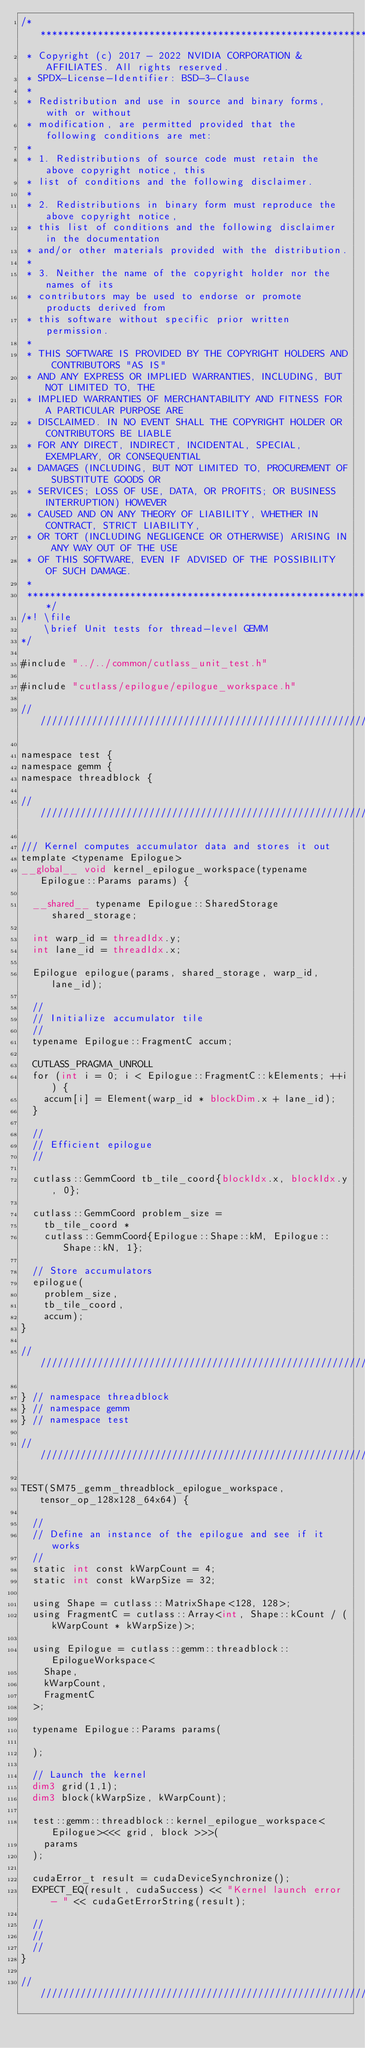Convert code to text. <code><loc_0><loc_0><loc_500><loc_500><_Cuda_>/***************************************************************************************************
 * Copyright (c) 2017 - 2022 NVIDIA CORPORATION & AFFILIATES. All rights reserved.
 * SPDX-License-Identifier: BSD-3-Clause
 *
 * Redistribution and use in source and binary forms, with or without
 * modification, are permitted provided that the following conditions are met:
 *
 * 1. Redistributions of source code must retain the above copyright notice, this
 * list of conditions and the following disclaimer.
 *
 * 2. Redistributions in binary form must reproduce the above copyright notice,
 * this list of conditions and the following disclaimer in the documentation
 * and/or other materials provided with the distribution.
 *
 * 3. Neither the name of the copyright holder nor the names of its
 * contributors may be used to endorse or promote products derived from
 * this software without specific prior written permission.
 *
 * THIS SOFTWARE IS PROVIDED BY THE COPYRIGHT HOLDERS AND CONTRIBUTORS "AS IS"
 * AND ANY EXPRESS OR IMPLIED WARRANTIES, INCLUDING, BUT NOT LIMITED TO, THE
 * IMPLIED WARRANTIES OF MERCHANTABILITY AND FITNESS FOR A PARTICULAR PURPOSE ARE
 * DISCLAIMED. IN NO EVENT SHALL THE COPYRIGHT HOLDER OR CONTRIBUTORS BE LIABLE
 * FOR ANY DIRECT, INDIRECT, INCIDENTAL, SPECIAL, EXEMPLARY, OR CONSEQUENTIAL
 * DAMAGES (INCLUDING, BUT NOT LIMITED TO, PROCUREMENT OF SUBSTITUTE GOODS OR
 * SERVICES; LOSS OF USE, DATA, OR PROFITS; OR BUSINESS INTERRUPTION) HOWEVER
 * CAUSED AND ON ANY THEORY OF LIABILITY, WHETHER IN CONTRACT, STRICT LIABILITY,
 * OR TORT (INCLUDING NEGLIGENCE OR OTHERWISE) ARISING IN ANY WAY OUT OF THE USE
 * OF THIS SOFTWARE, EVEN IF ADVISED OF THE POSSIBILITY OF SUCH DAMAGE.
 *
 **************************************************************************************************/
/*! \file
    \brief Unit tests for thread-level GEMM
*/

#include "../../common/cutlass_unit_test.h"

#include "cutlass/epilogue/epilogue_workspace.h"

/////////////////////////////////////////////////////////////////////////////////////////////////

namespace test {
namespace gemm {
namespace threadblock {

/////////////////////////////////////////////////////////////////////////////////////////////////

/// Kernel computes accumulator data and stores it out
template <typename Epilogue>
__global__ void kernel_epilogue_workspace(typename Epilogue::Params params) {

  __shared__ typename Epilogue::SharedStorage shared_storage;

  int warp_id = threadIdx.y;
  int lane_id = threadIdx.x;

  Epilogue epilogue(params, shared_storage, warp_id, lane_id);

  //
  // Initialize accumulator tile
  //
  typename Epilogue::FragmentC accum;

  CUTLASS_PRAGMA_UNROLL
  for (int i = 0; i < Epilogue::FragmentC::kElements; ++i) {
    accum[i] = Element(warp_id * blockDim.x + lane_id);
  }

  //
  // Efficient epilogue
  //

  cutlass::GemmCoord tb_tile_coord{blockIdx.x, blockIdx.y, 0};
  
  cutlass::GemmCoord problem_size = 
    tb_tile_coord * 
    cutlass::GemmCoord{Epilogue::Shape::kM, Epilogue::Shape::kN, 1};

  // Store accumulators
  epilogue(
    problem_size, 
    tb_tile_coord, 
    accum);
}

/////////////////////////////////////////////////////////////////////////////////////////////////

} // namespace threadblock
} // namespace gemm
} // namespace test

/////////////////////////////////////////////////////////////////////////////////////////////////

TEST(SM75_gemm_threadblock_epilogue_workspace, tensor_op_128x128_64x64) {

  //
  // Define an instance of the epilogue and see if it works
  //
  static int const kWarpCount = 4;
  static int const kWarpSize = 32;

  using Shape = cutlass::MatrixShape<128, 128>;
  using FragmentC = cutlass::Array<int, Shape::kCount / (kWarpCount * kWarpSize)>;

  using Epilogue = cutlass::gemm::threadblock::EpilogueWorkspace<
    Shape,
    kWarpCount,
    FragmentC
  >;

  typename Epilogue::Params params(
    
  );

  // Launch the kernel
  dim3 grid(1,1);
  dim3 block(kWarpSize, kWarpCount);

  test::gemm::threadblock::kernel_epilogue_workspace<Epilogue><<< grid, block >>>(
    params
  );

  cudaError_t result = cudaDeviceSynchronize();
  EXPECT_EQ(result, cudaSuccess) << "Kernel launch error - " << cudaGetErrorString(result);

  //
  // 
  //
}

/////////////////////////////////////////////////////////////////////////////////////////////////
</code> 